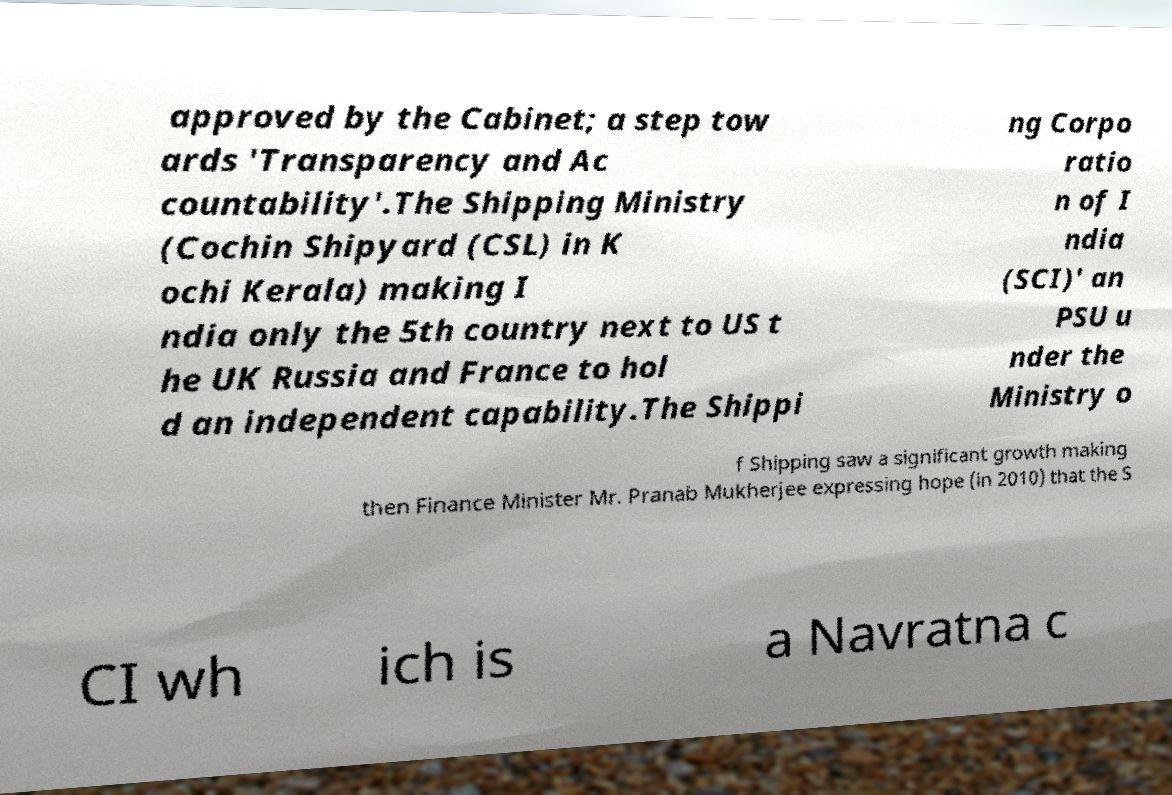Can you read and provide the text displayed in the image?This photo seems to have some interesting text. Can you extract and type it out for me? approved by the Cabinet; a step tow ards 'Transparency and Ac countability'.The Shipping Ministry (Cochin Shipyard (CSL) in K ochi Kerala) making I ndia only the 5th country next to US t he UK Russia and France to hol d an independent capability.The Shippi ng Corpo ratio n of I ndia (SCI)' an PSU u nder the Ministry o f Shipping saw a significant growth making then Finance Minister Mr. Pranab Mukherjee expressing hope (in 2010) that the S CI wh ich is a Navratna c 